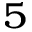Convert formula to latex. <formula><loc_0><loc_0><loc_500><loc_500>^ { 5 }</formula> 